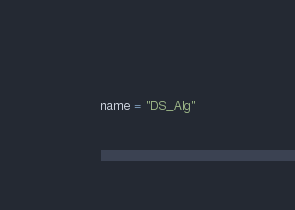<code> <loc_0><loc_0><loc_500><loc_500><_Python_>name = "DS_Alg"</code> 